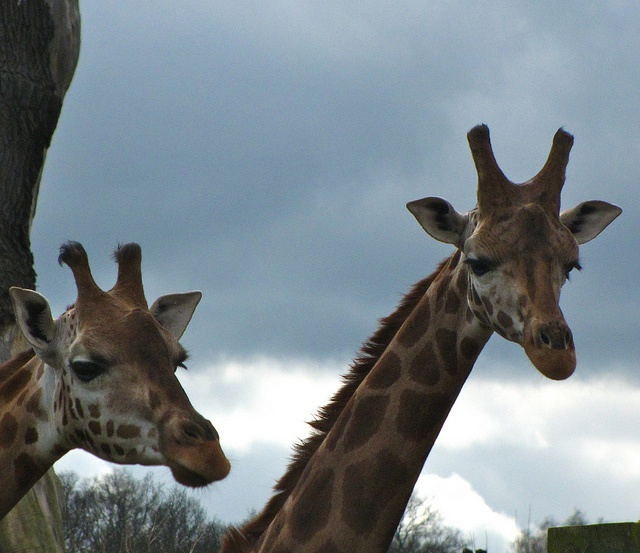Describe the objects in this image and their specific colors. I can see giraffe in black and gray tones and giraffe in black and gray tones in this image. 